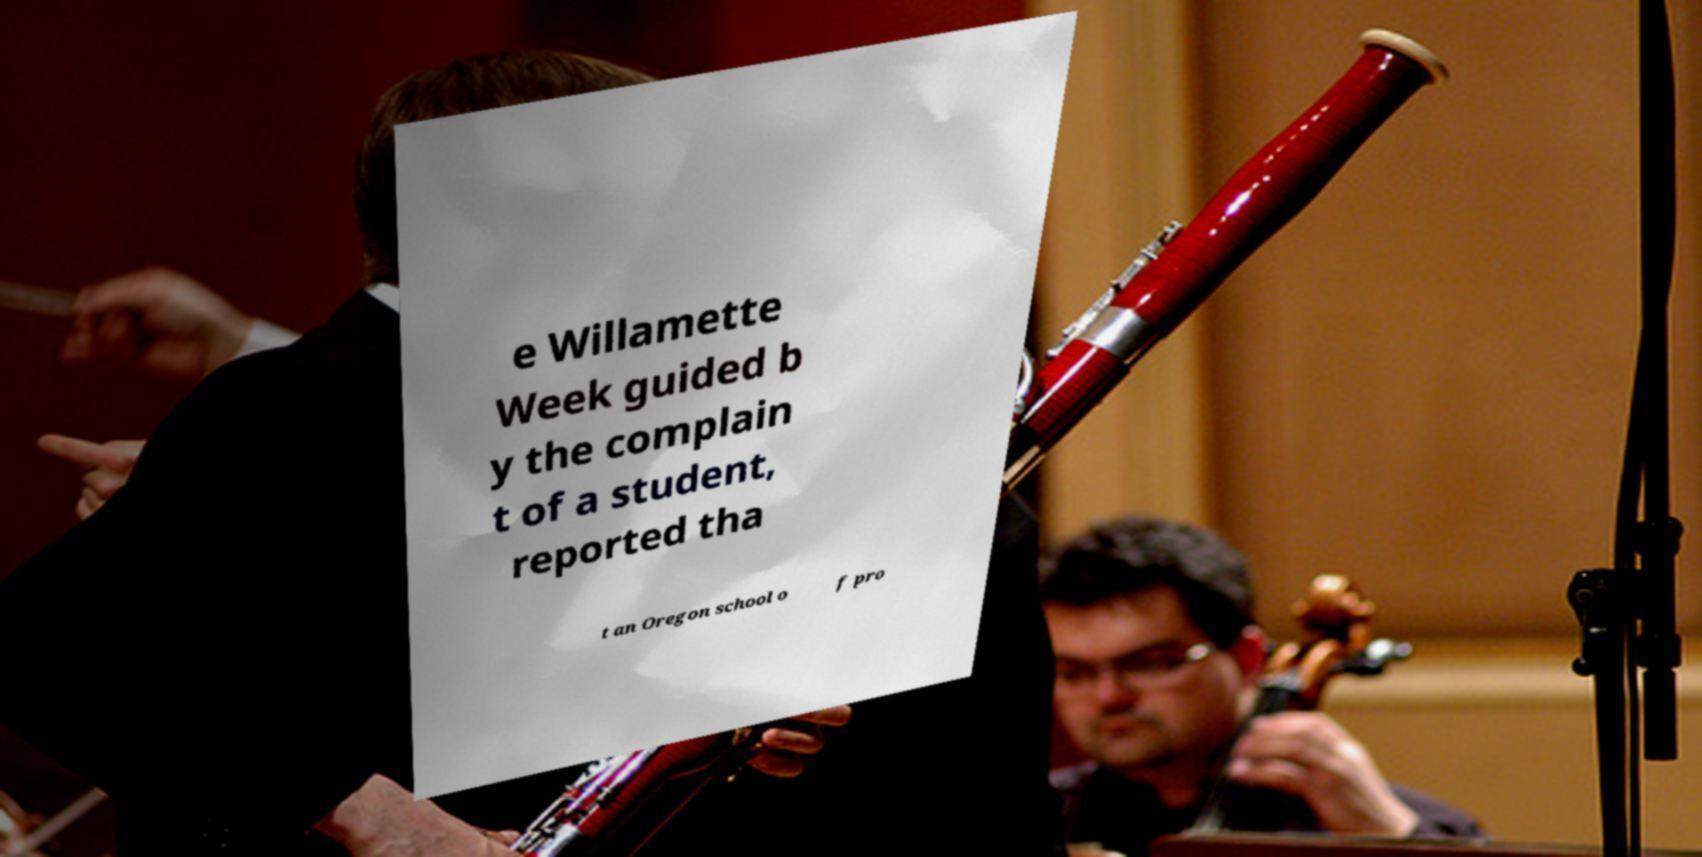I need the written content from this picture converted into text. Can you do that? e Willamette Week guided b y the complain t of a student, reported tha t an Oregon school o f pro 